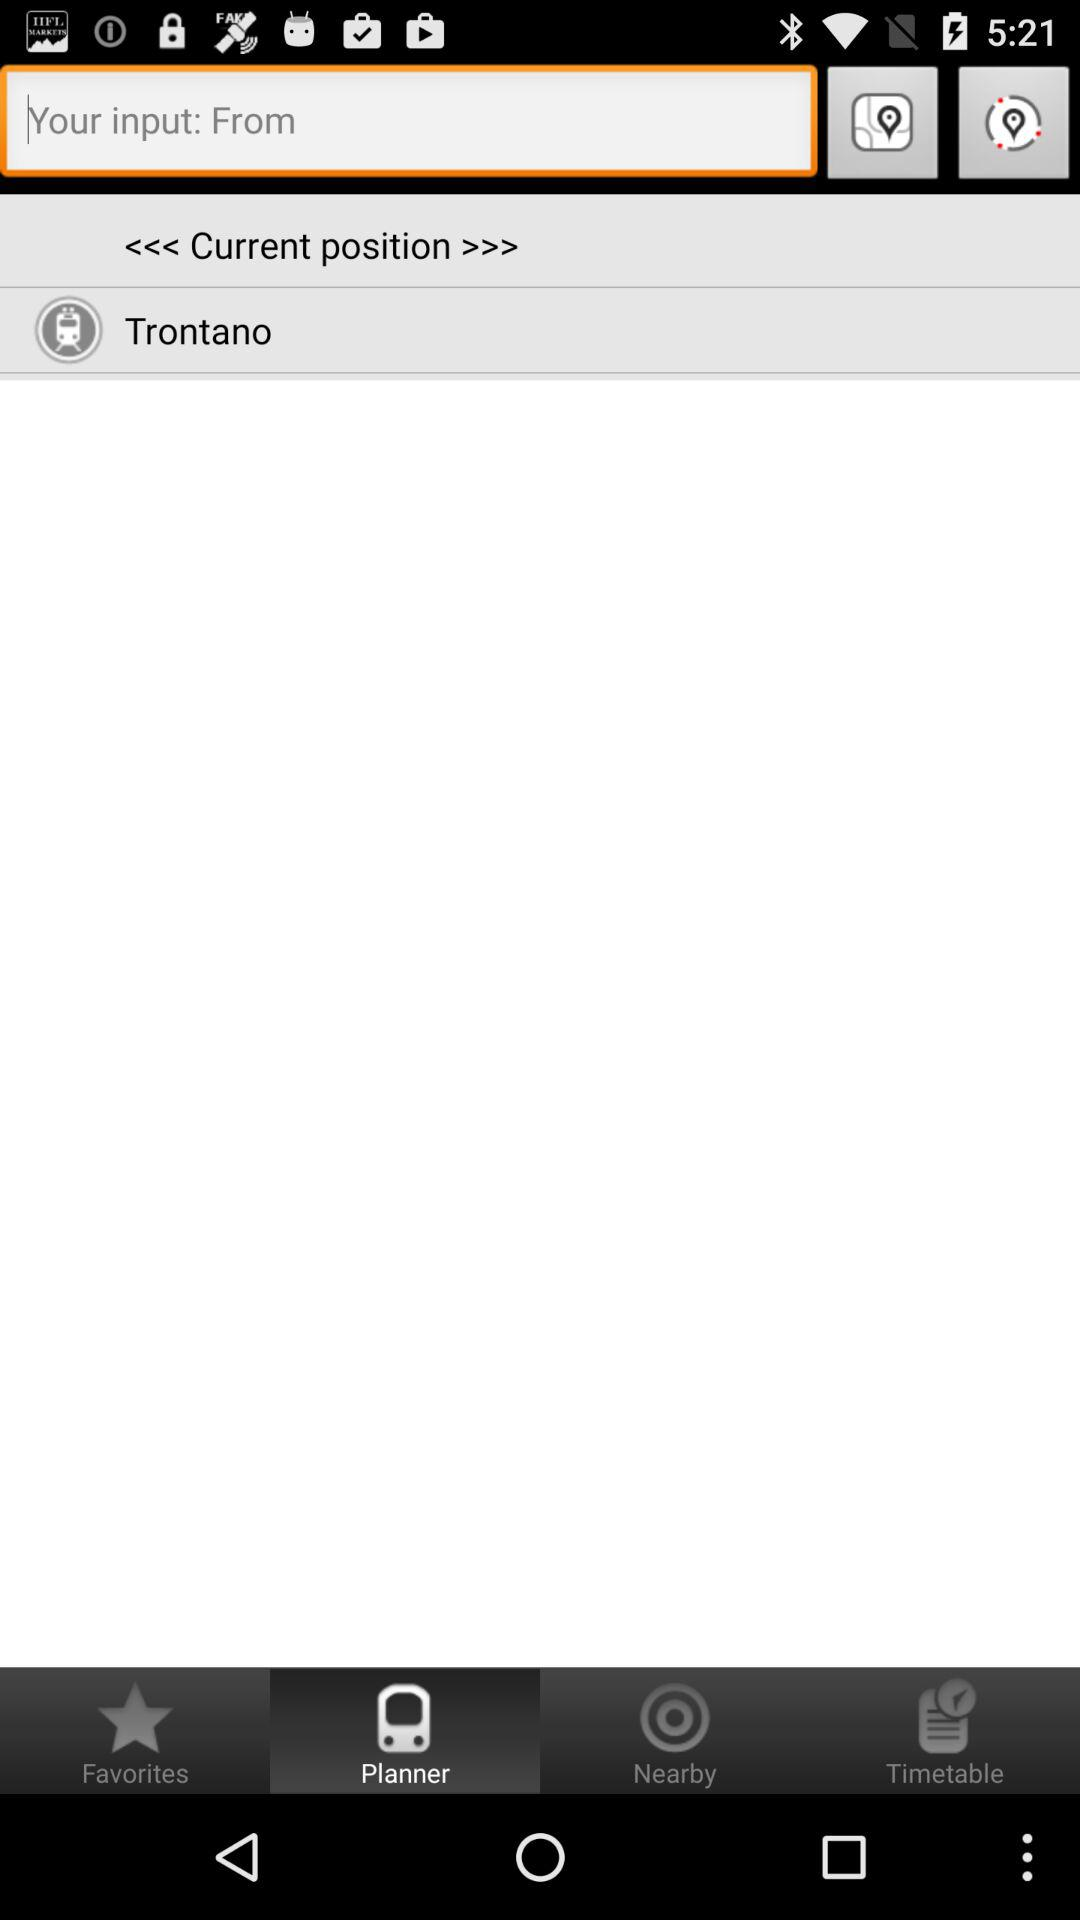Which tab is selected? The selected tab is "Planner". 